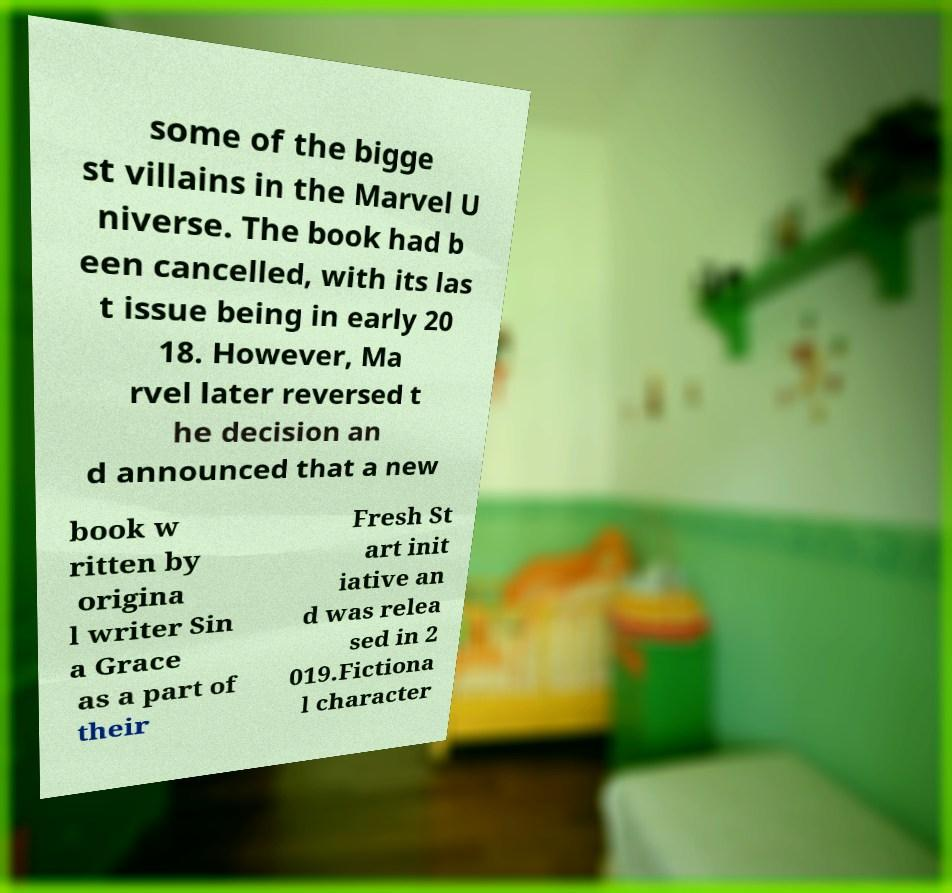There's text embedded in this image that I need extracted. Can you transcribe it verbatim? some of the bigge st villains in the Marvel U niverse. The book had b een cancelled, with its las t issue being in early 20 18. However, Ma rvel later reversed t he decision an d announced that a new book w ritten by origina l writer Sin a Grace as a part of their Fresh St art init iative an d was relea sed in 2 019.Fictiona l character 